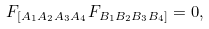Convert formula to latex. <formula><loc_0><loc_0><loc_500><loc_500>F _ { [ A _ { 1 } A _ { 2 } A _ { 3 } A _ { 4 } } F _ { B _ { 1 } B _ { 2 } B _ { 3 } B _ { 4 } ] } = 0 ,</formula> 